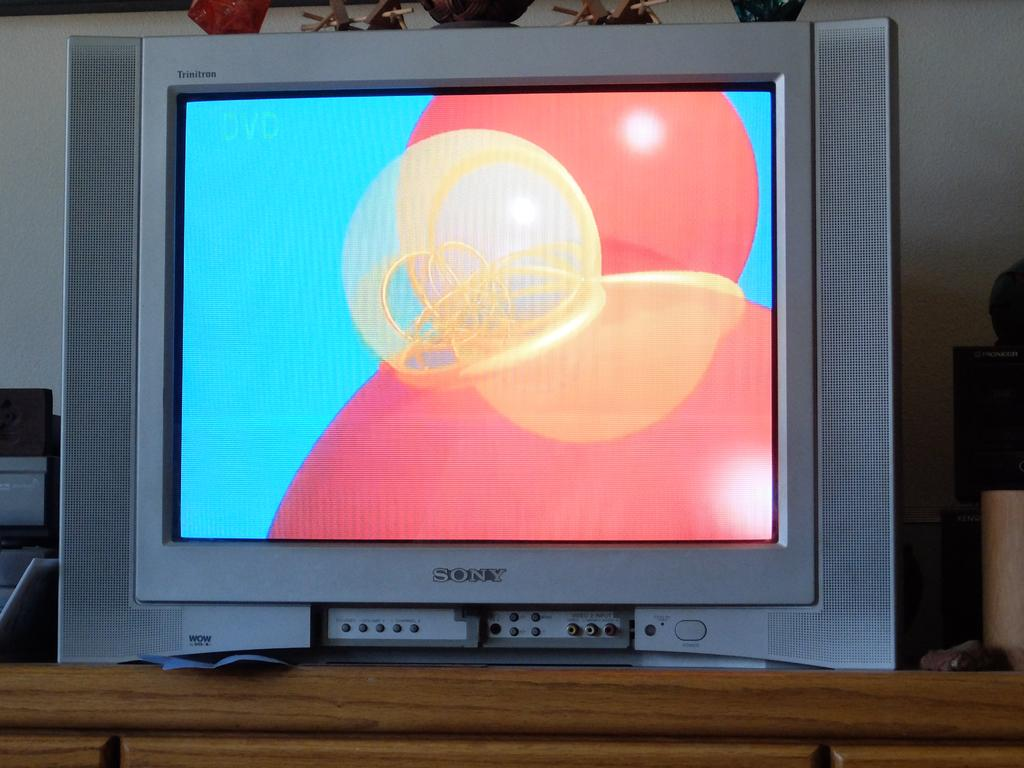Provide a one-sentence caption for the provided image. A Sony TV screen that is turned on. 